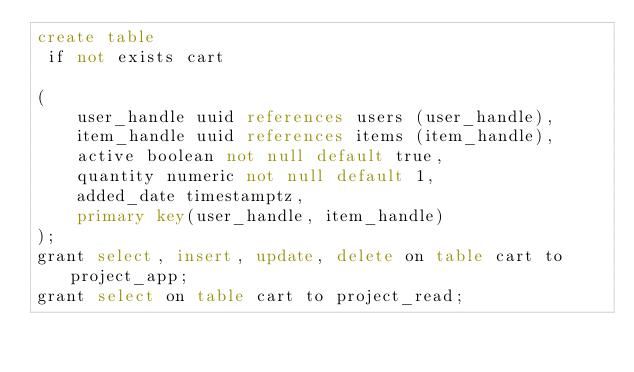<code> <loc_0><loc_0><loc_500><loc_500><_SQL_>create table                                                                                                                                                                                                                                                                                                                                                                            
 if not exists cart

(  
    user_handle uuid references users (user_handle),
    item_handle uuid references items (item_handle),
    active boolean not null default true,
    quantity numeric not null default 1,
    added_date timestamptz,
    primary key(user_handle, item_handle)
);
grant select, insert, update, delete on table cart to project_app;
grant select on table cart to project_read;           </code> 